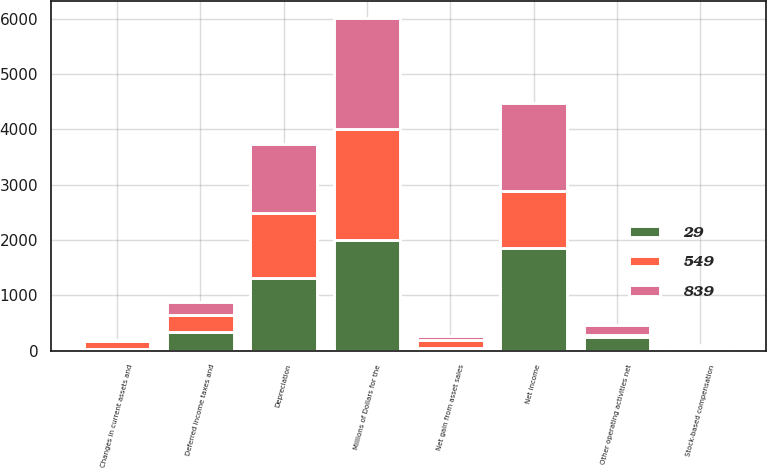Convert chart. <chart><loc_0><loc_0><loc_500><loc_500><stacked_bar_chart><ecel><fcel>Millions of Dollars for the<fcel>Net income<fcel>Depreciation<fcel>Deferred income taxes and<fcel>Stock-based compensation<fcel>Net gain from asset sales<fcel>Other operating activities net<fcel>Changes in current assets and<nl><fcel>29<fcel>2007<fcel>1855<fcel>1321<fcel>332<fcel>44<fcel>52<fcel>251<fcel>28<nl><fcel>839<fcel>2006<fcel>1606<fcel>1237<fcel>235<fcel>35<fcel>72<fcel>175<fcel>14<nl><fcel>549<fcel>2005<fcel>1026<fcel>1175<fcel>320<fcel>21<fcel>135<fcel>37<fcel>151<nl></chart> 